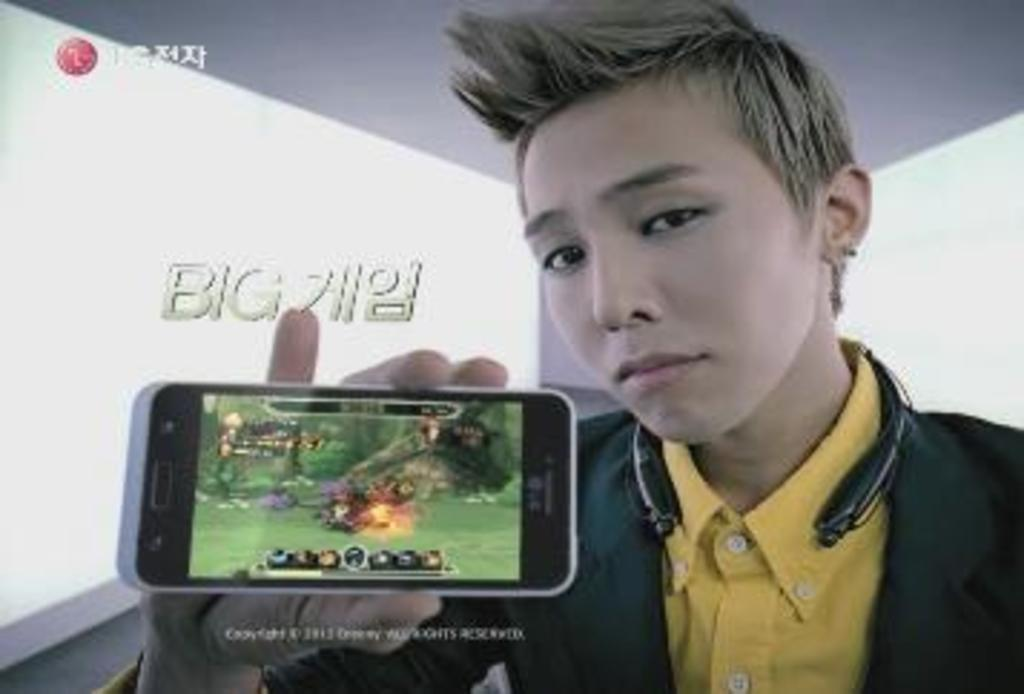Who is in the image? There is a man in the image. What is the man holding in his hand? The man is holding a mobile in his hand. What is the man doing with the mobile? The man is showing the mobile to the camera. What other object can be seen in the image? There is a bluetooth speaker in the image. What type of gold jewelry is the man wearing in the image? There is no gold jewelry visible on the man in the image. How does the man rub the boat in the image? There is no boat present in the image, and therefore no rubbing can be observed. 